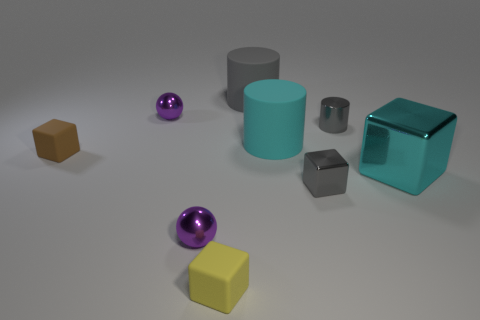There is a cyan cylinder; does it have the same size as the rubber block behind the yellow matte object? The cyan cylinder appears to be taller but with a smaller diameter compared to the rubber block behind the yellow matte object, suggesting they do not have the same size. Differences in height and diameter contribute to their overall volume, so their sizes are not equivalent. 